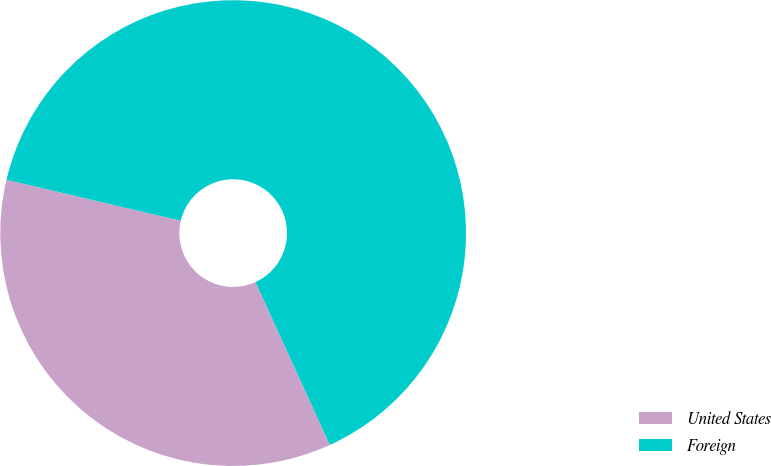Convert chart to OTSL. <chart><loc_0><loc_0><loc_500><loc_500><pie_chart><fcel>United States<fcel>Foreign<nl><fcel>35.49%<fcel>64.51%<nl></chart> 